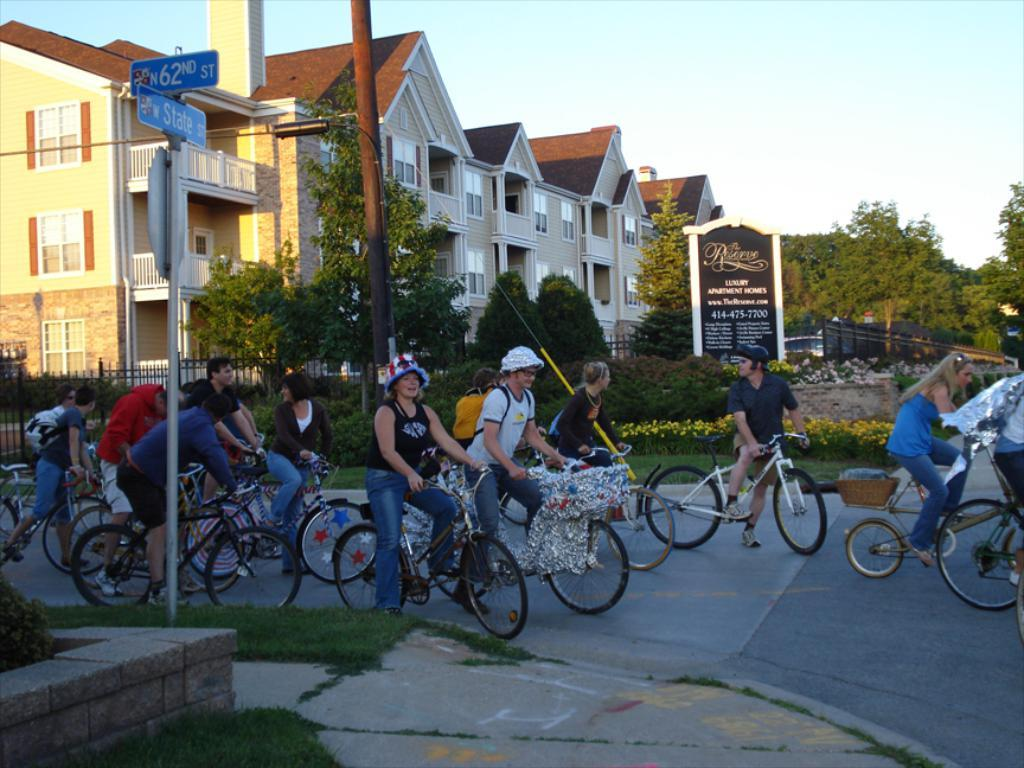Who or what is present in the image? There are people in the image. What are the people doing in the image? The people are sitting on bicycles. Where are the bicycles located in the image? The bicycles are on the road. What can be seen in the background of the image? There are trees and buildings visible in the image. What type of relation does the science have with the parent in the image? There is no mention of science or parent in the image, so this question cannot be answered. 